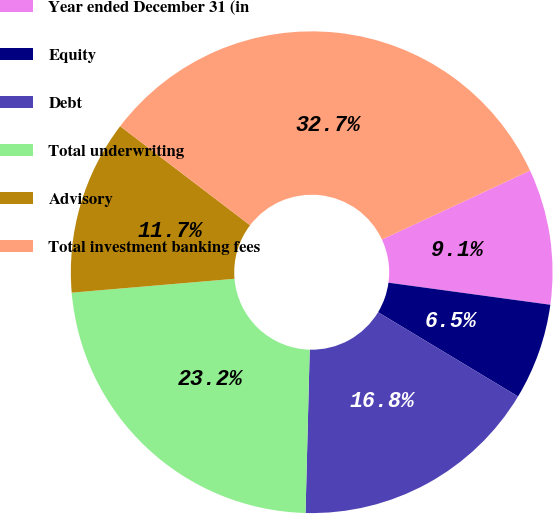Convert chart. <chart><loc_0><loc_0><loc_500><loc_500><pie_chart><fcel>Year ended December 31 (in<fcel>Equity<fcel>Debt<fcel>Total underwriting<fcel>Advisory<fcel>Total investment banking fees<nl><fcel>9.09%<fcel>6.47%<fcel>16.78%<fcel>23.24%<fcel>11.72%<fcel>32.7%<nl></chart> 